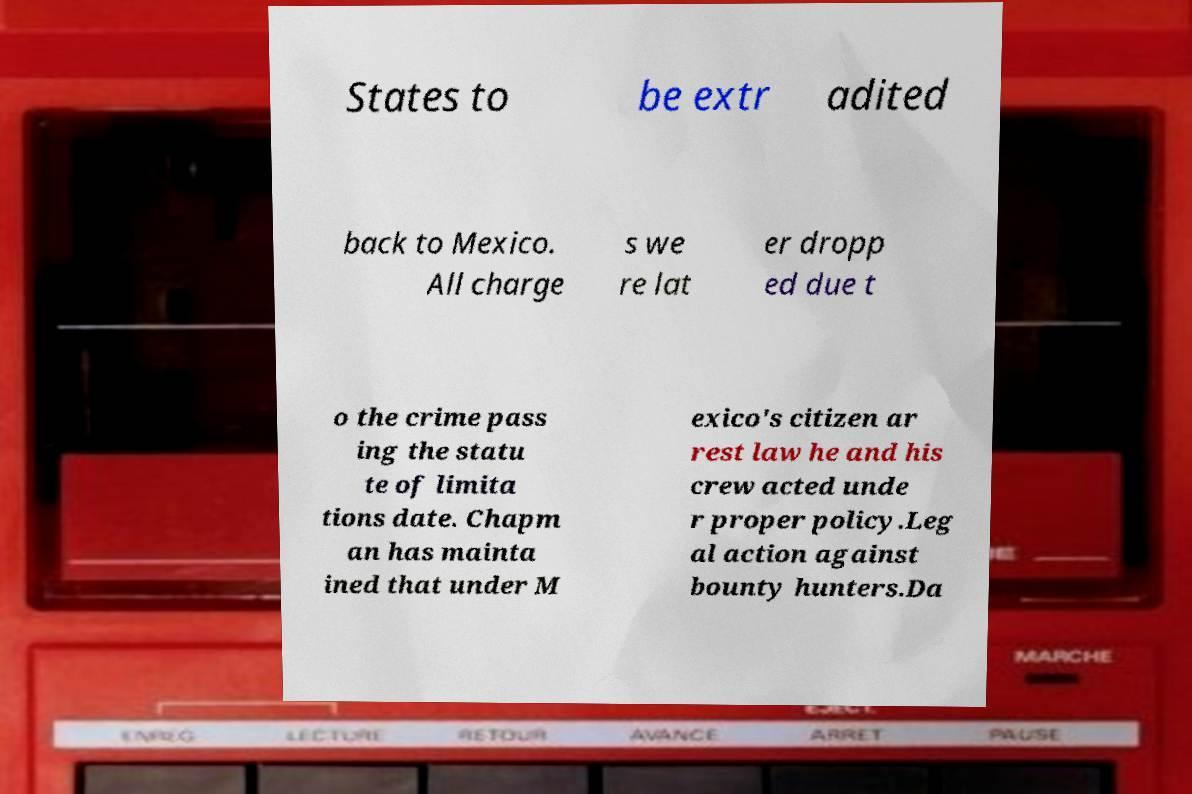Can you accurately transcribe the text from the provided image for me? States to be extr adited back to Mexico. All charge s we re lat er dropp ed due t o the crime pass ing the statu te of limita tions date. Chapm an has mainta ined that under M exico's citizen ar rest law he and his crew acted unde r proper policy.Leg al action against bounty hunters.Da 